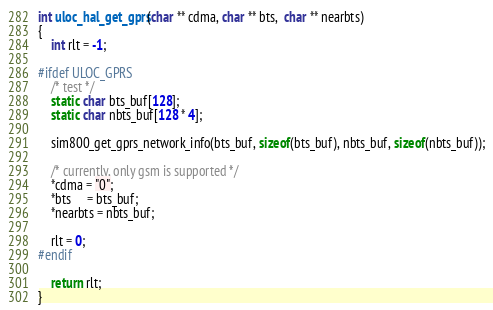Convert code to text. <code><loc_0><loc_0><loc_500><loc_500><_C_>int uloc_hal_get_gprs(char ** cdma, char ** bts,  char ** nearbts)
{
    int rlt = -1;

#ifdef ULOC_GPRS
    /* test */
    static char bts_buf[128];
    static char nbts_buf[128 * 4];

    sim800_get_gprs_network_info(bts_buf, sizeof(bts_buf), nbts_buf, sizeof(nbts_buf));

    /* currently, only gsm is supported */
    *cdma = "0";
    *bts     = bts_buf;
    *nearbts = nbts_buf;

    rlt = 0;
#endif

    return rlt;
}

</code> 